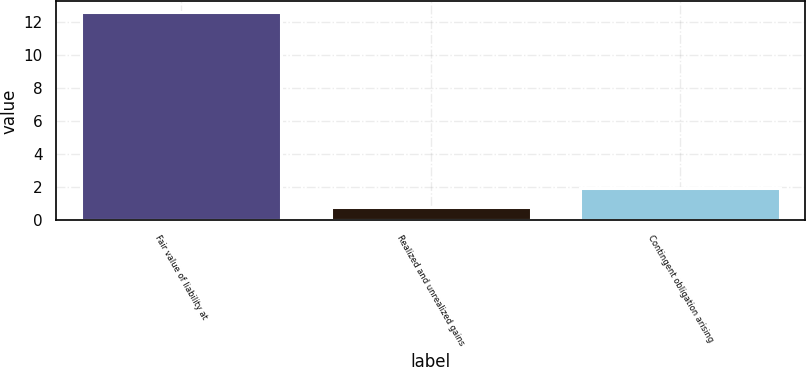<chart> <loc_0><loc_0><loc_500><loc_500><bar_chart><fcel>Fair value of liability at<fcel>Realized and unrealized gains<fcel>Contingent obligation arising<nl><fcel>12.6<fcel>0.8<fcel>1.98<nl></chart> 